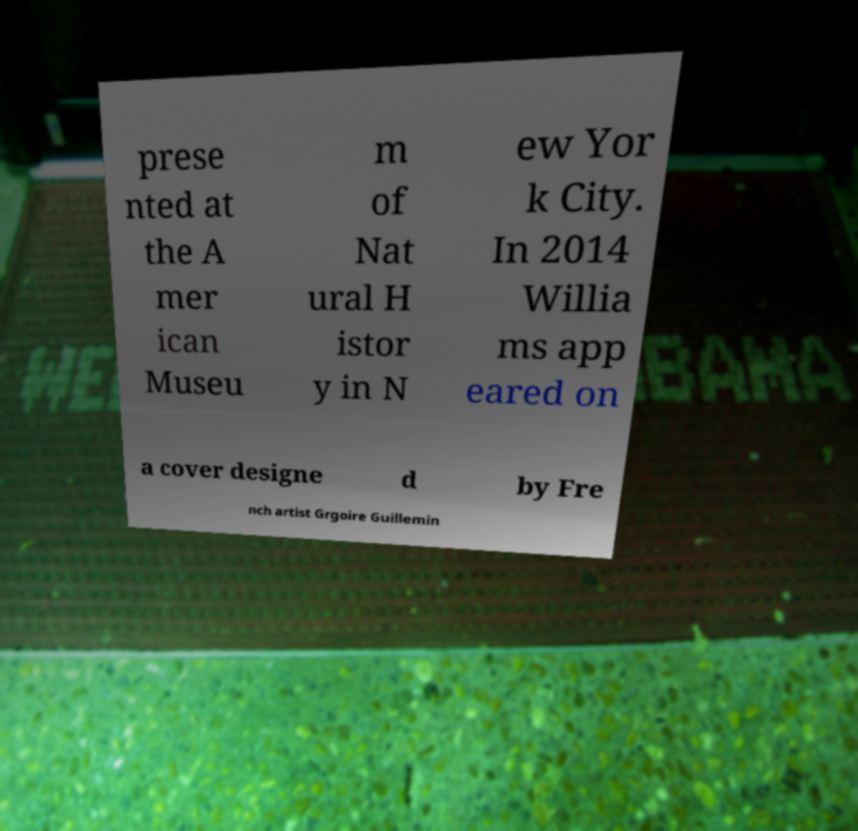For documentation purposes, I need the text within this image transcribed. Could you provide that? prese nted at the A mer ican Museu m of Nat ural H istor y in N ew Yor k City. In 2014 Willia ms app eared on a cover designe d by Fre nch artist Grgoire Guillemin 